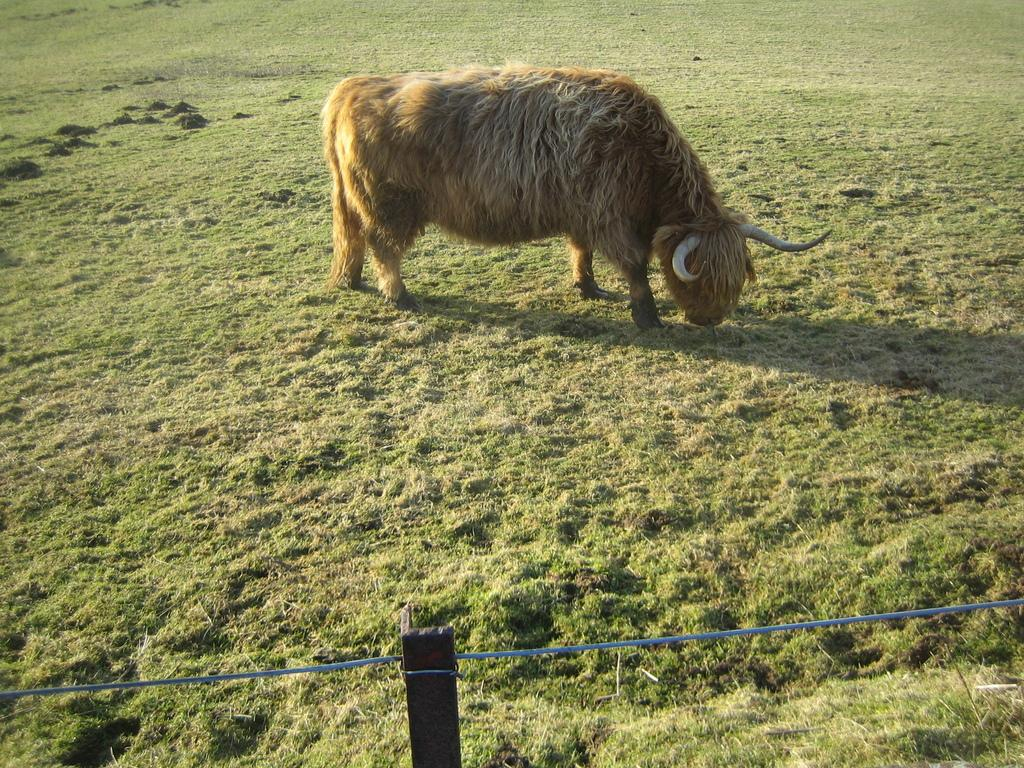What type of animal can be seen in the image? There is an animal in the image. What is the animal doing in the image? The animal is eating grass. Where is the animal located in the image? The animal is on the ground. What can be seen in the background of the image? There is a fence with wooden poles in the image. What type of vegetation is present on the ground in the image? There is grass on the ground in the image. What type of cakes can be seen on the animal's back in the image? There are no cakes present in the image; the animal is eating grass. Can you tell me how many squirrels are visible in the image? There is no squirrel present in the image; the animal is not specified as a squirrel. 